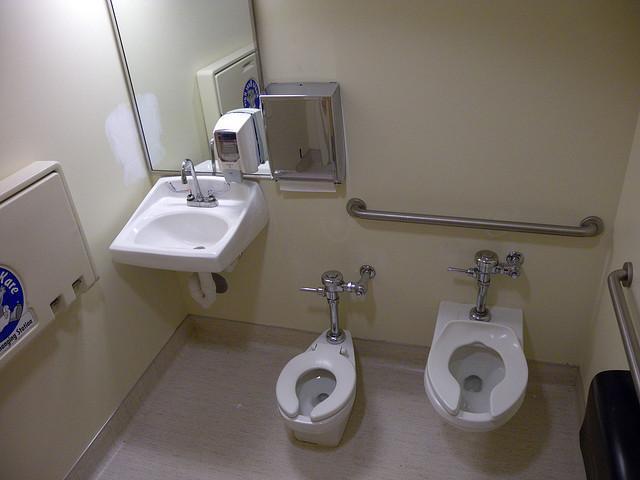How many toilets are there?
Give a very brief answer. 2. How many sinks are in the photo?
Give a very brief answer. 1. 